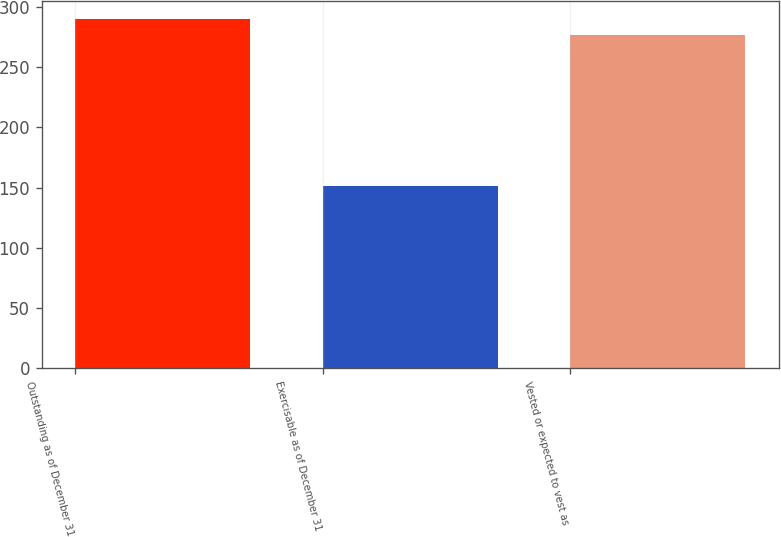Convert chart. <chart><loc_0><loc_0><loc_500><loc_500><bar_chart><fcel>Outstanding as of December 31<fcel>Exercisable as of December 31<fcel>Vested or expected to vest as<nl><fcel>290.21<fcel>151.3<fcel>277<nl></chart> 